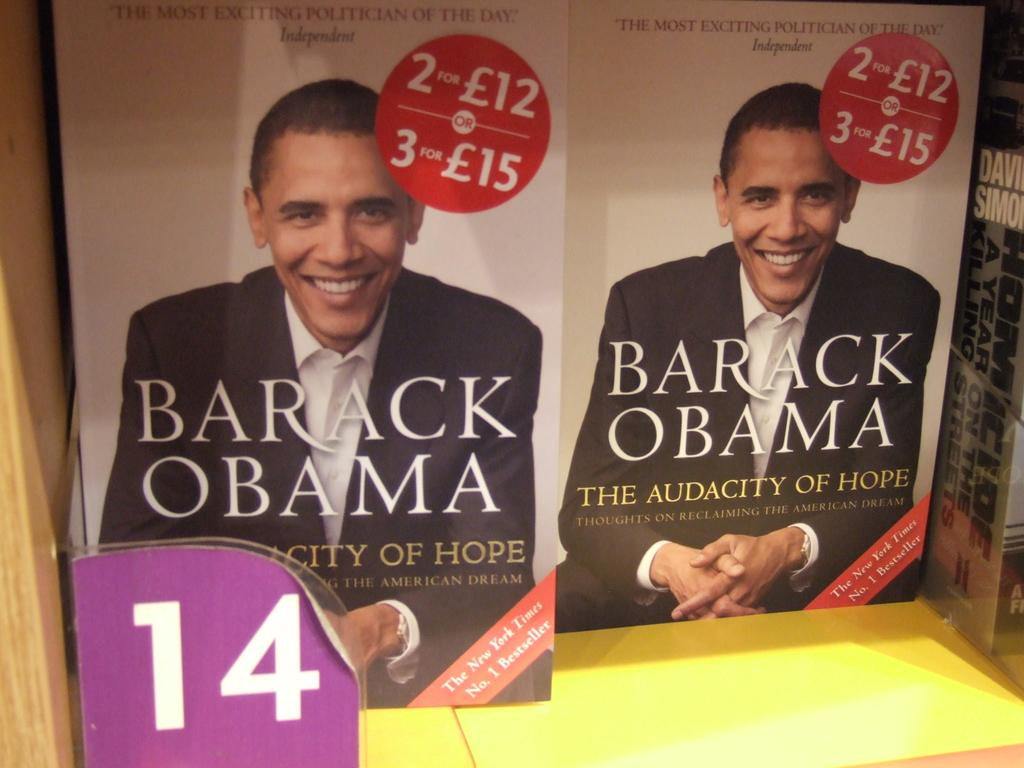Provide a one-sentence caption for the provided image. Two copies of a book titled, Barack Obama - The Audacity of Hope being advertised. 